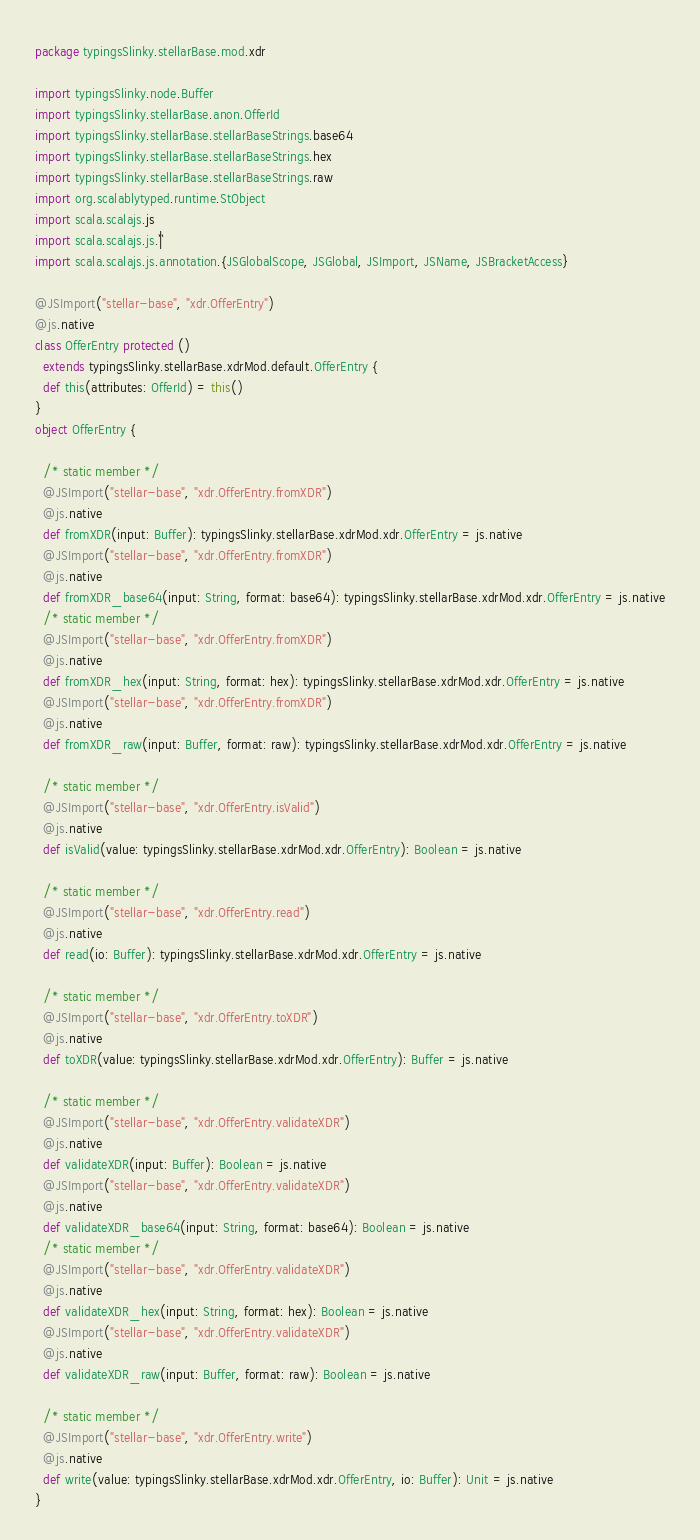<code> <loc_0><loc_0><loc_500><loc_500><_Scala_>package typingsSlinky.stellarBase.mod.xdr

import typingsSlinky.node.Buffer
import typingsSlinky.stellarBase.anon.OfferId
import typingsSlinky.stellarBase.stellarBaseStrings.base64
import typingsSlinky.stellarBase.stellarBaseStrings.hex
import typingsSlinky.stellarBase.stellarBaseStrings.raw
import org.scalablytyped.runtime.StObject
import scala.scalajs.js
import scala.scalajs.js.`|`
import scala.scalajs.js.annotation.{JSGlobalScope, JSGlobal, JSImport, JSName, JSBracketAccess}

@JSImport("stellar-base", "xdr.OfferEntry")
@js.native
class OfferEntry protected ()
  extends typingsSlinky.stellarBase.xdrMod.default.OfferEntry {
  def this(attributes: OfferId) = this()
}
object OfferEntry {
  
  /* static member */
  @JSImport("stellar-base", "xdr.OfferEntry.fromXDR")
  @js.native
  def fromXDR(input: Buffer): typingsSlinky.stellarBase.xdrMod.xdr.OfferEntry = js.native
  @JSImport("stellar-base", "xdr.OfferEntry.fromXDR")
  @js.native
  def fromXDR_base64(input: String, format: base64): typingsSlinky.stellarBase.xdrMod.xdr.OfferEntry = js.native
  /* static member */
  @JSImport("stellar-base", "xdr.OfferEntry.fromXDR")
  @js.native
  def fromXDR_hex(input: String, format: hex): typingsSlinky.stellarBase.xdrMod.xdr.OfferEntry = js.native
  @JSImport("stellar-base", "xdr.OfferEntry.fromXDR")
  @js.native
  def fromXDR_raw(input: Buffer, format: raw): typingsSlinky.stellarBase.xdrMod.xdr.OfferEntry = js.native
  
  /* static member */
  @JSImport("stellar-base", "xdr.OfferEntry.isValid")
  @js.native
  def isValid(value: typingsSlinky.stellarBase.xdrMod.xdr.OfferEntry): Boolean = js.native
  
  /* static member */
  @JSImport("stellar-base", "xdr.OfferEntry.read")
  @js.native
  def read(io: Buffer): typingsSlinky.stellarBase.xdrMod.xdr.OfferEntry = js.native
  
  /* static member */
  @JSImport("stellar-base", "xdr.OfferEntry.toXDR")
  @js.native
  def toXDR(value: typingsSlinky.stellarBase.xdrMod.xdr.OfferEntry): Buffer = js.native
  
  /* static member */
  @JSImport("stellar-base", "xdr.OfferEntry.validateXDR")
  @js.native
  def validateXDR(input: Buffer): Boolean = js.native
  @JSImport("stellar-base", "xdr.OfferEntry.validateXDR")
  @js.native
  def validateXDR_base64(input: String, format: base64): Boolean = js.native
  /* static member */
  @JSImport("stellar-base", "xdr.OfferEntry.validateXDR")
  @js.native
  def validateXDR_hex(input: String, format: hex): Boolean = js.native
  @JSImport("stellar-base", "xdr.OfferEntry.validateXDR")
  @js.native
  def validateXDR_raw(input: Buffer, format: raw): Boolean = js.native
  
  /* static member */
  @JSImport("stellar-base", "xdr.OfferEntry.write")
  @js.native
  def write(value: typingsSlinky.stellarBase.xdrMod.xdr.OfferEntry, io: Buffer): Unit = js.native
}
</code> 